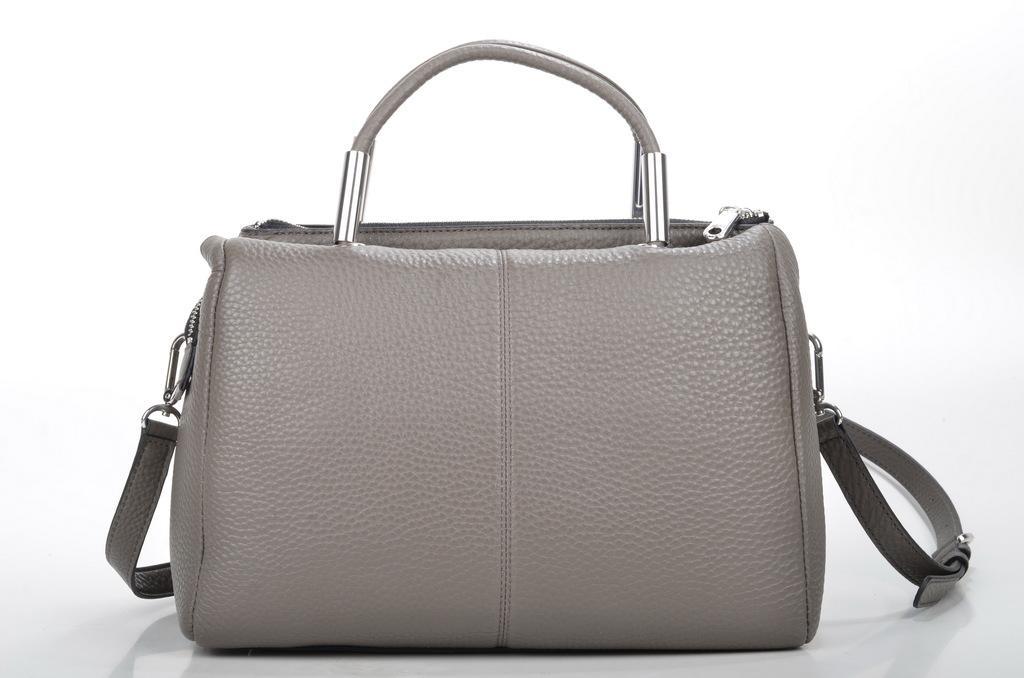Describe this image in one or two sentences. This is a picture of the grey colour handbag. 